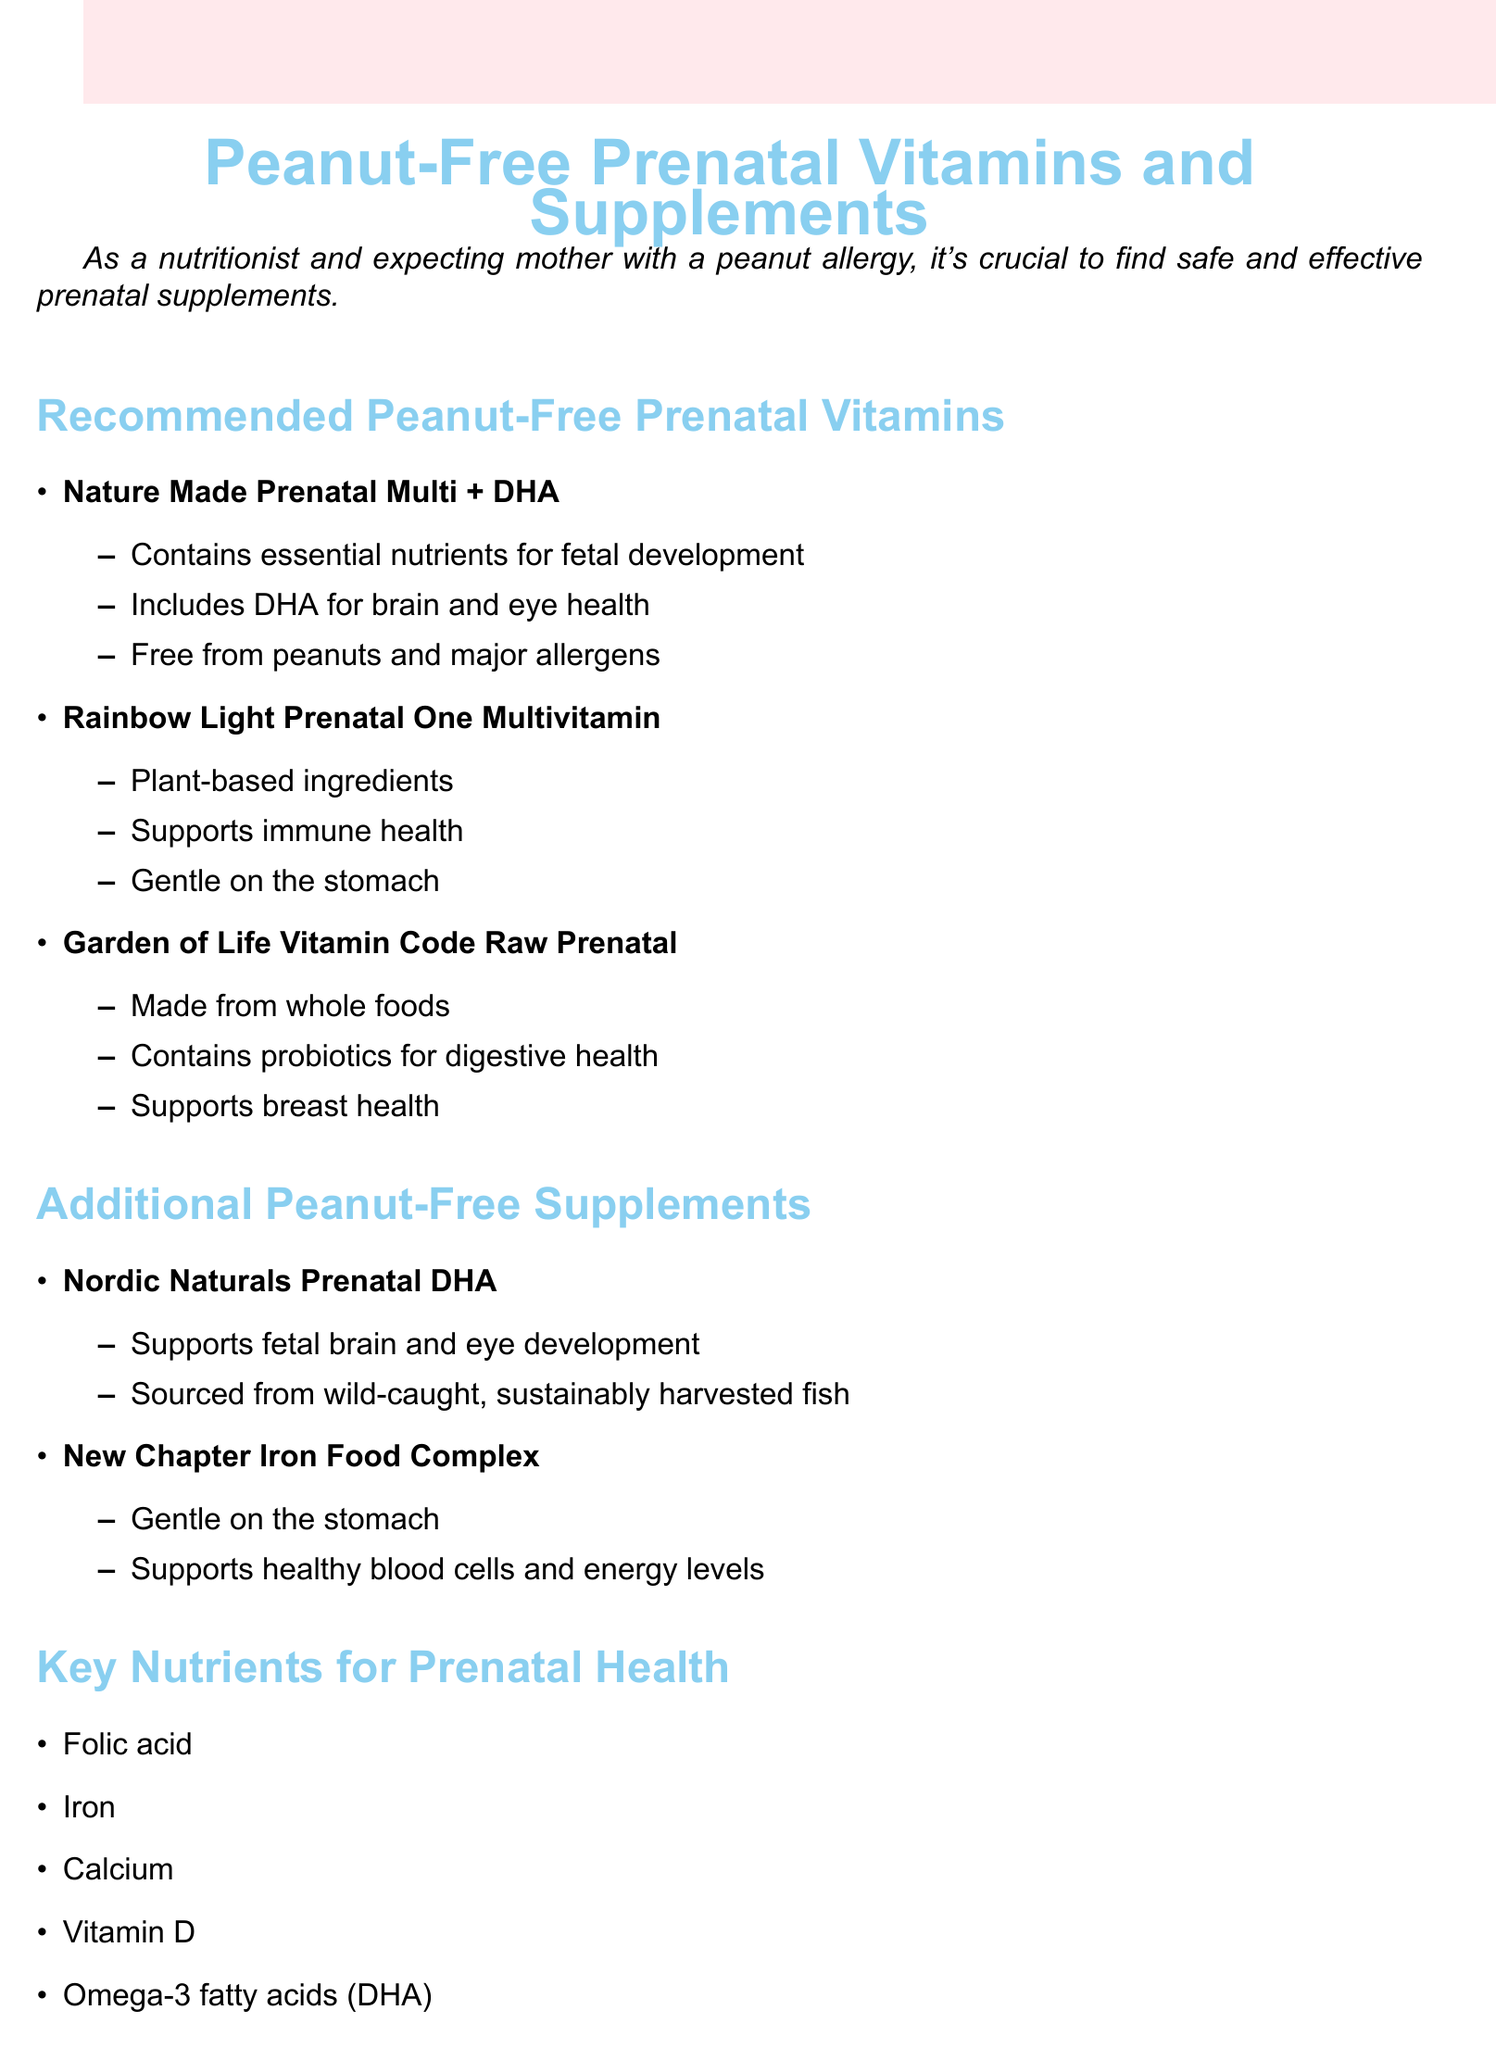What is the title of the document? The title is presented at the top of the document.
Answer: Peanut-Free Prenatal Vitamins and Supplements What is a benefit of Nature Made Prenatal Multi + DHA? The document lists several benefits for this supplement.
Answer: Contains essential nutrients for fetal development Which supplement supports healthy blood cells and energy levels? The document mentions this benefit specifically for one of the additional supplements.
Answer: New Chapter Iron Food Complex What is one key nutrient mentioned for prenatal health? The document lists several key nutrients necessary for prenatal health.
Answer: Folic acid How many peanut-free prenatal vitamins are listed in the document? This is calculated by counting the items under that section.
Answer: Three What should you do before starting any new supplements? The document provides safety tips regarding the usage of supplements.
Answer: Consult with your healthcare provider Which supplement is made from whole foods? The document specifies which prenatal vitamin is made from this category of ingredients.
Answer: Garden of Life Vitamin Code Raw Prenatal What type of ingredients does Rainbow Light Prenatal One Multivitamin contain? The document explicitly describes the type of ingredients used in this supplement.
Answer: Plant-based ingredients What is a safety tip mentioned in the document? The document outlines several safety tips for the use of supplements.
Answer: Always check ingredient lists for potential allergens 